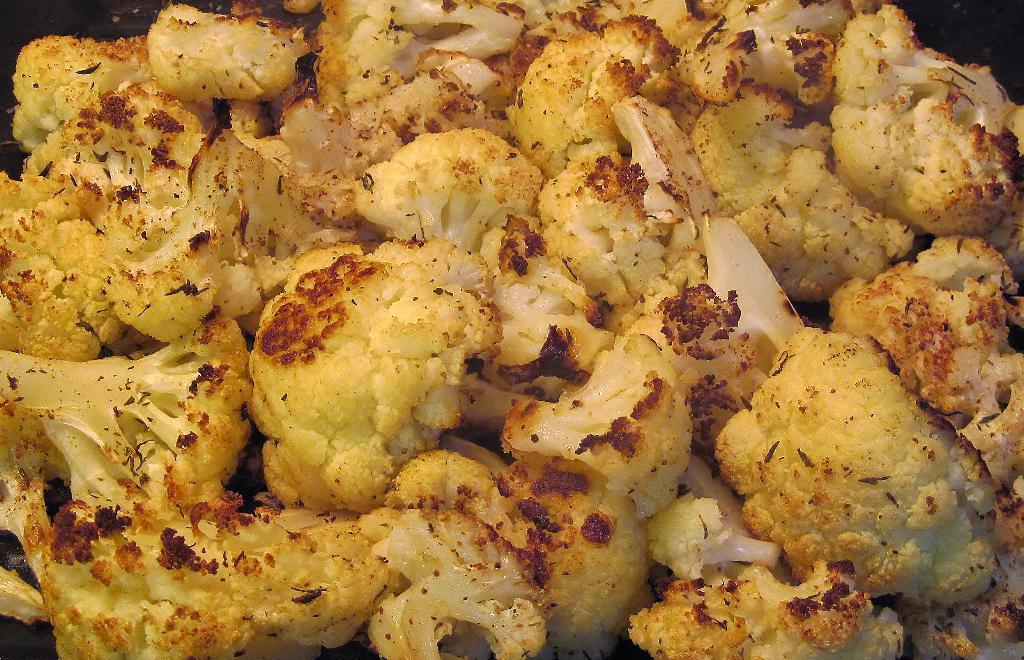What type of vegetable is present in the image? There are yellow pieces of cauliflower in the image. What type of soup is being served in the airplane during the hour depicted in the image? There is no soup, airplane, or hour depicted in the image; it only shows yellow pieces of cauliflower. 